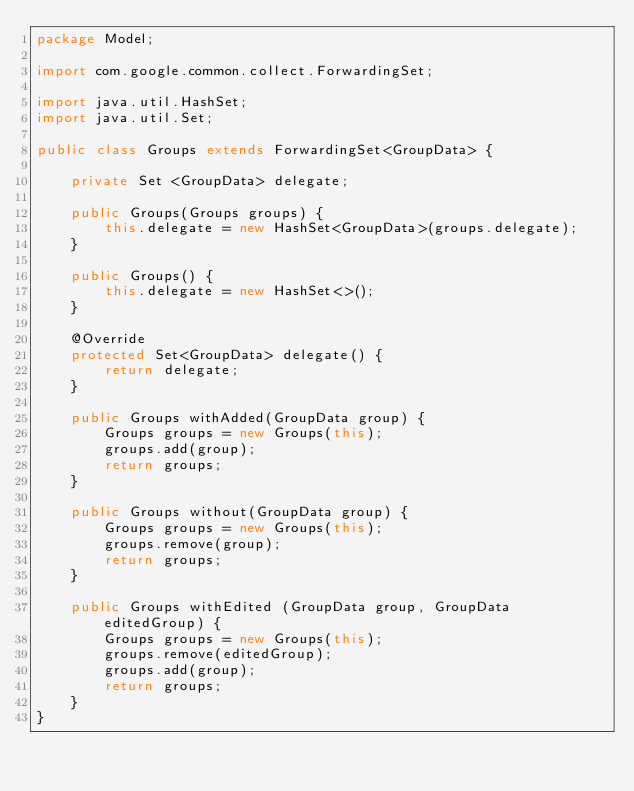Convert code to text. <code><loc_0><loc_0><loc_500><loc_500><_Java_>package Model;

import com.google.common.collect.ForwardingSet;

import java.util.HashSet;
import java.util.Set;

public class Groups extends ForwardingSet<GroupData> {

    private Set <GroupData> delegate;

    public Groups(Groups groups) {
        this.delegate = new HashSet<GroupData>(groups.delegate);
    }

    public Groups() {
        this.delegate = new HashSet<>();
    }

    @Override
    protected Set<GroupData> delegate() {
        return delegate;
    }

    public Groups withAdded(GroupData group) {
        Groups groups = new Groups(this);
        groups.add(group);
        return groups;
    }

    public Groups without(GroupData group) {
        Groups groups = new Groups(this);
        groups.remove(group);
        return groups;
    }

    public Groups withEdited (GroupData group, GroupData editedGroup) {
        Groups groups = new Groups(this);
        groups.remove(editedGroup);
        groups.add(group);
        return groups;
    }
}
</code> 